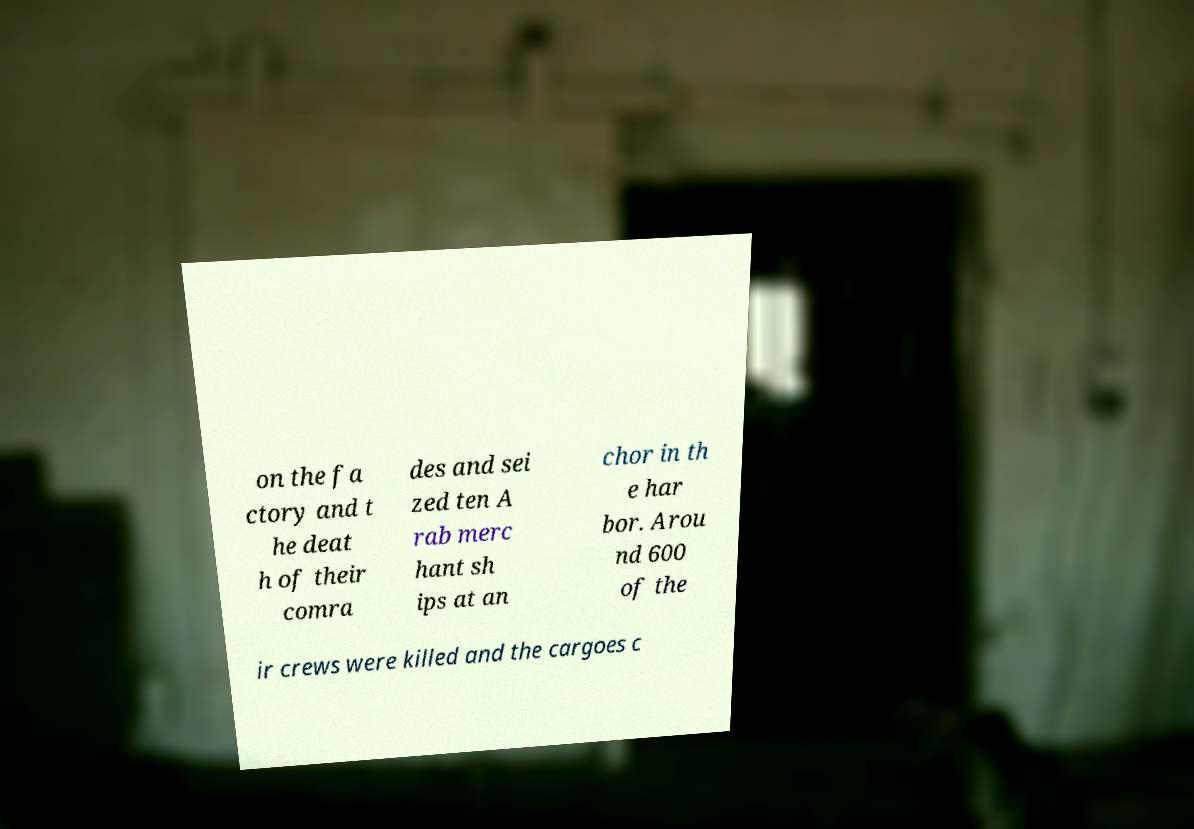I need the written content from this picture converted into text. Can you do that? on the fa ctory and t he deat h of their comra des and sei zed ten A rab merc hant sh ips at an chor in th e har bor. Arou nd 600 of the ir crews were killed and the cargoes c 